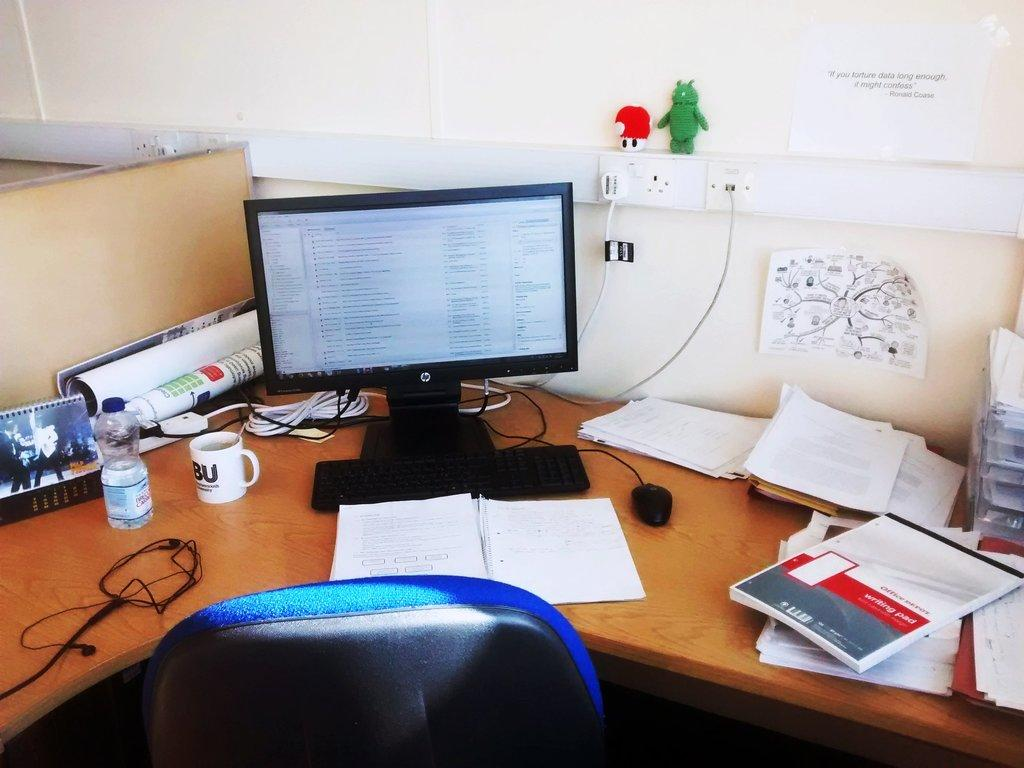What electronic device is visible in the image? There is a monitor in the image. What input device is present for the computer? There is a computer mouse in the image. What can be seen for hydration purposes? There is a water bottle in the image. What other objects are present on the table? There are other objects on the table, but their specific details are not mentioned in the facts. What type of furniture is in the image? There is a chair in the image. What type of note can be seen on the monitor in the image? There is no note visible on the monitor in the image. What season is depicted by the spring flowers on the table? There is no mention of spring flowers or any flowers in the image. 